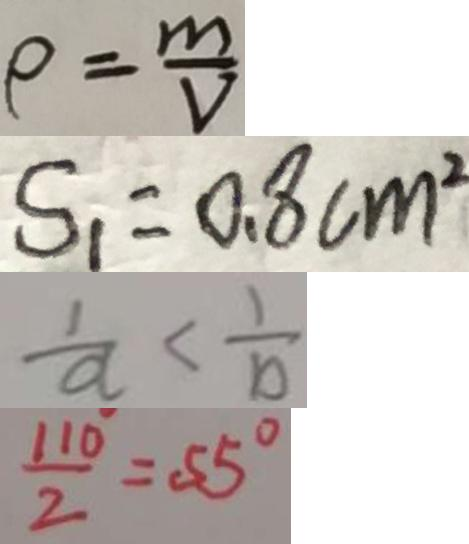<formula> <loc_0><loc_0><loc_500><loc_500>\rho = \frac { m } { V } 
 S _ { 1 } = 0 . 8 c m ^ { 2 } 
 \frac { 1 } { a } < \frac { 1 } { b } 
 \frac { 1 1 0 } { 2 } = 5 5 ^ { \circ }</formula> 